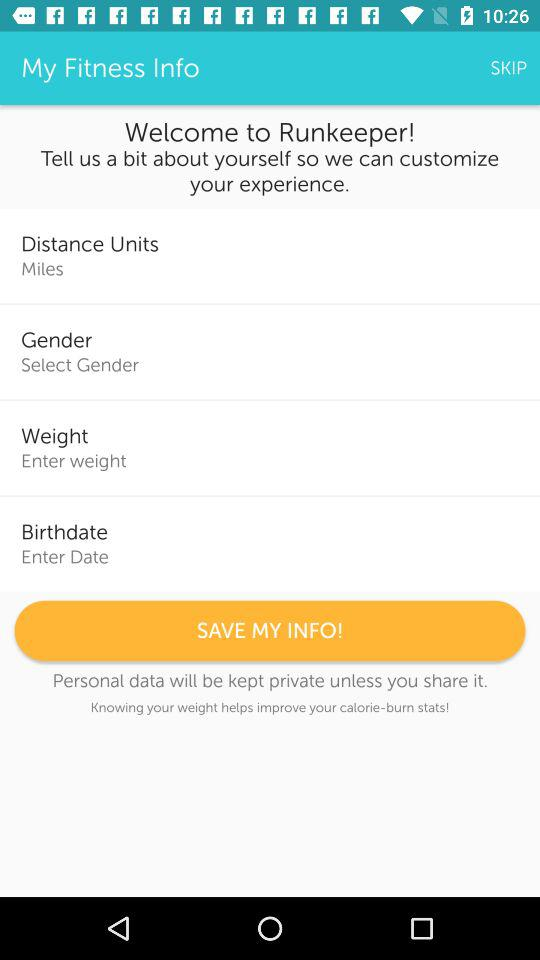How long will personal data remain private? Personal data will remain private unless you share it. 